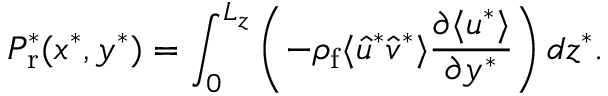Convert formula to latex. <formula><loc_0><loc_0><loc_500><loc_500>P _ { r } ^ { * } ( x ^ { * } , y ^ { * } ) = \int _ { 0 } ^ { L _ { z } } \left ( - \rho _ { f } \langle \hat { u } ^ { * } \hat { v } ^ { * } \rangle \frac { \partial \langle u ^ { * } \rangle } { \partial y ^ { * } } \right ) d z ^ { * } .</formula> 